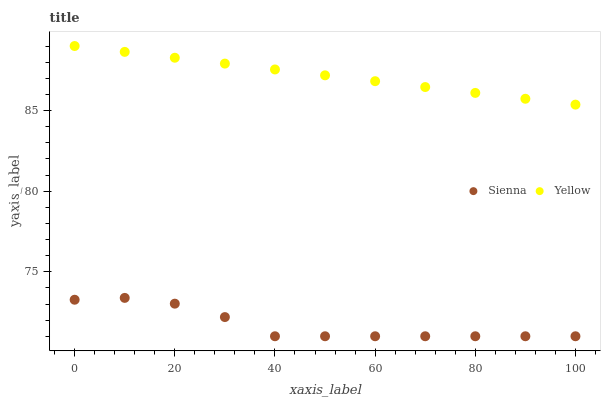Does Sienna have the minimum area under the curve?
Answer yes or no. Yes. Does Yellow have the maximum area under the curve?
Answer yes or no. Yes. Does Yellow have the minimum area under the curve?
Answer yes or no. No. Is Yellow the smoothest?
Answer yes or no. Yes. Is Sienna the roughest?
Answer yes or no. Yes. Is Yellow the roughest?
Answer yes or no. No. Does Sienna have the lowest value?
Answer yes or no. Yes. Does Yellow have the lowest value?
Answer yes or no. No. Does Yellow have the highest value?
Answer yes or no. Yes. Is Sienna less than Yellow?
Answer yes or no. Yes. Is Yellow greater than Sienna?
Answer yes or no. Yes. Does Sienna intersect Yellow?
Answer yes or no. No. 